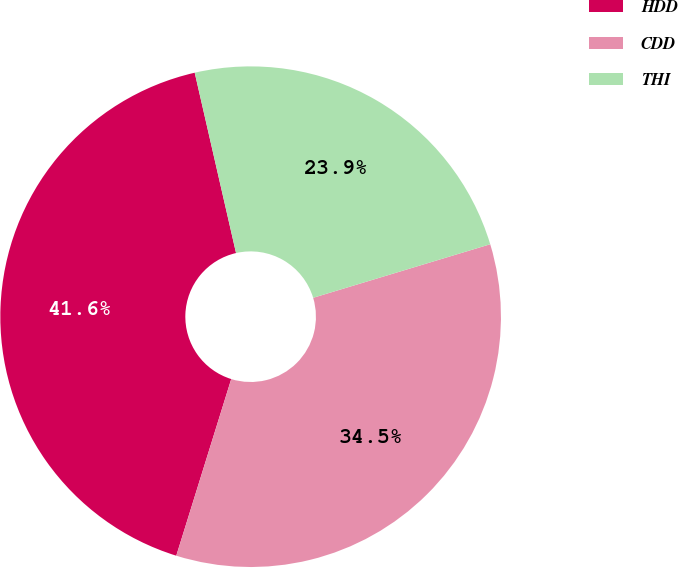Convert chart to OTSL. <chart><loc_0><loc_0><loc_500><loc_500><pie_chart><fcel>HDD<fcel>CDD<fcel>THI<nl><fcel>41.61%<fcel>34.47%<fcel>23.91%<nl></chart> 